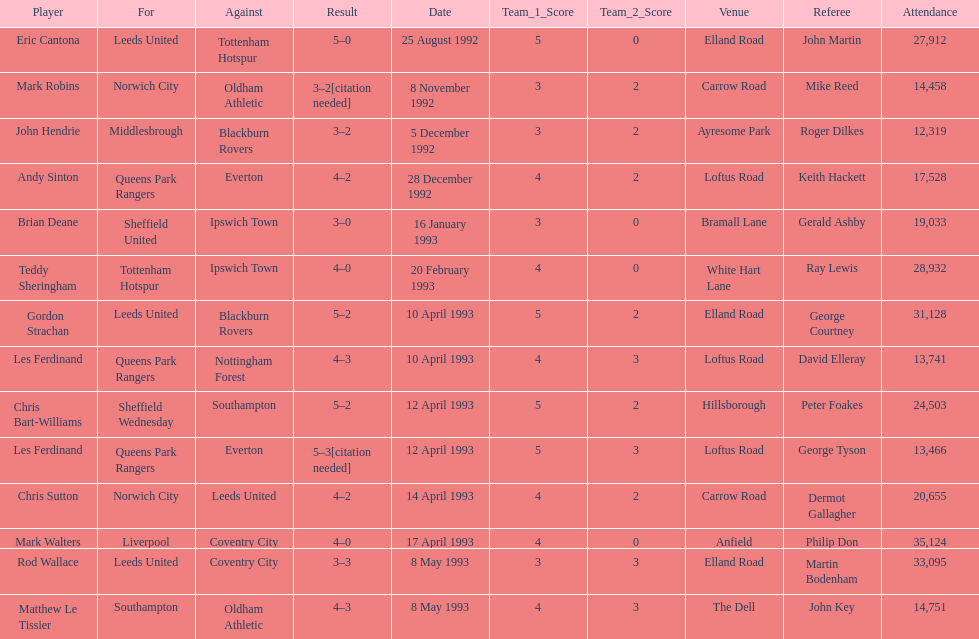In the 1992-1993 premier league, what was the total number of hat tricks scored by all players? 14. 